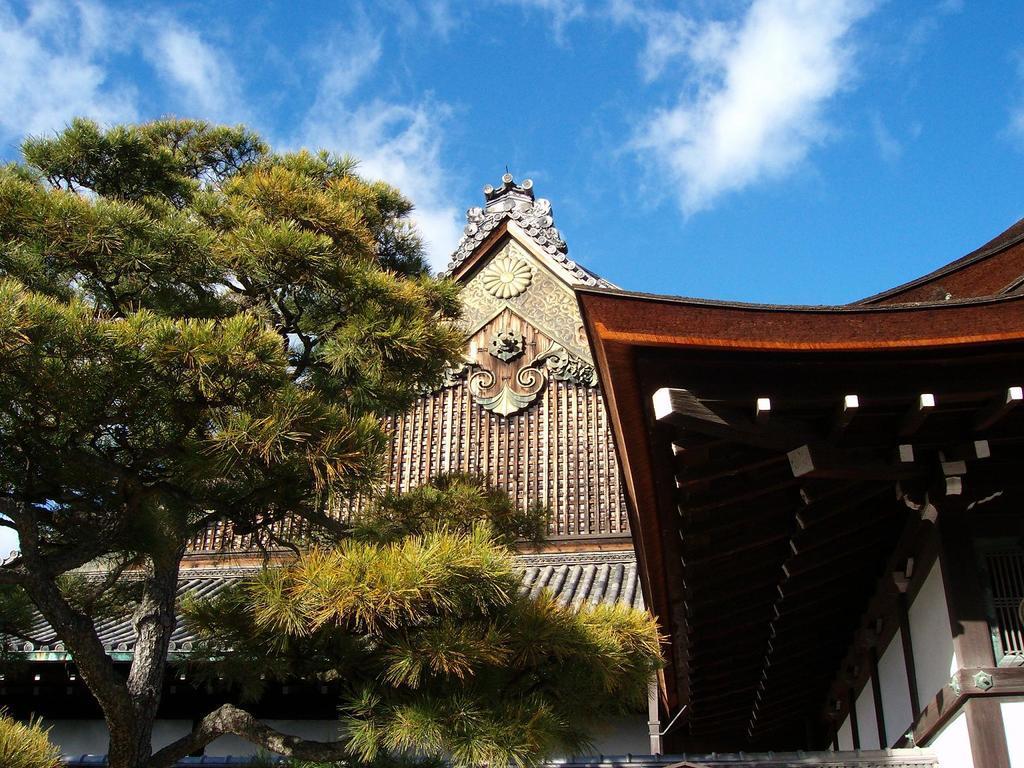Can you describe this image briefly? In this image we can see trees and buildings. In the background we can see sky and clouds. 